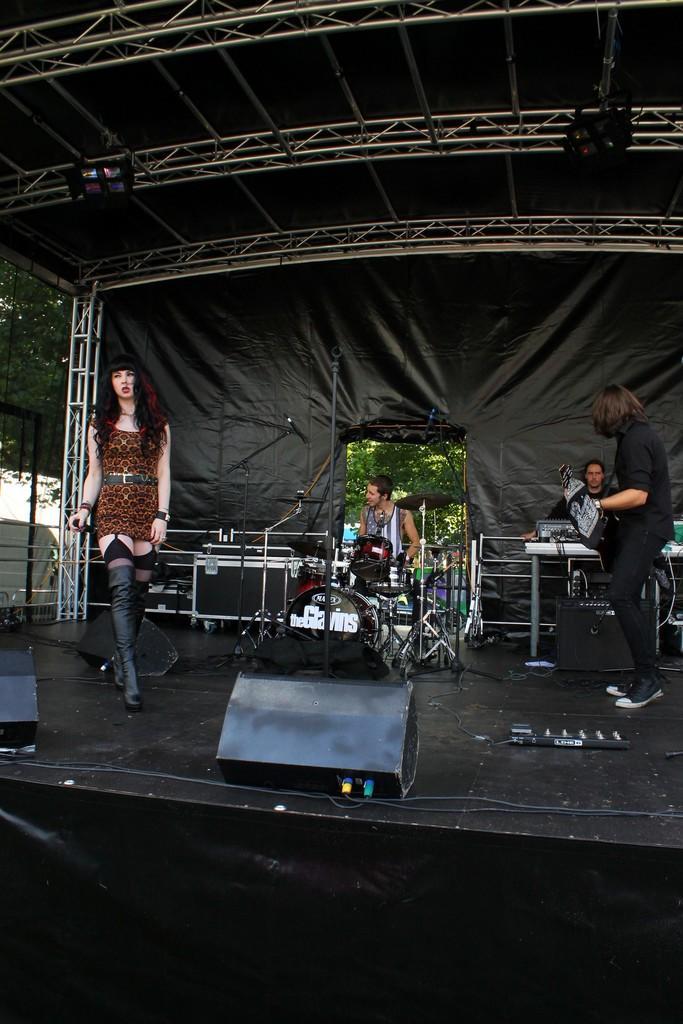How would you summarize this image in a sentence or two? In this image there is a woman wearing a brown colour dress is having boots. A person standing at the right side is wearing a black colour shirt is wearing shoes. Behind him there is a person before a table. At the middle of image there is a person sitting before a musical instrument. There are few lights hanged to the rods. At the left side there are few trees. 